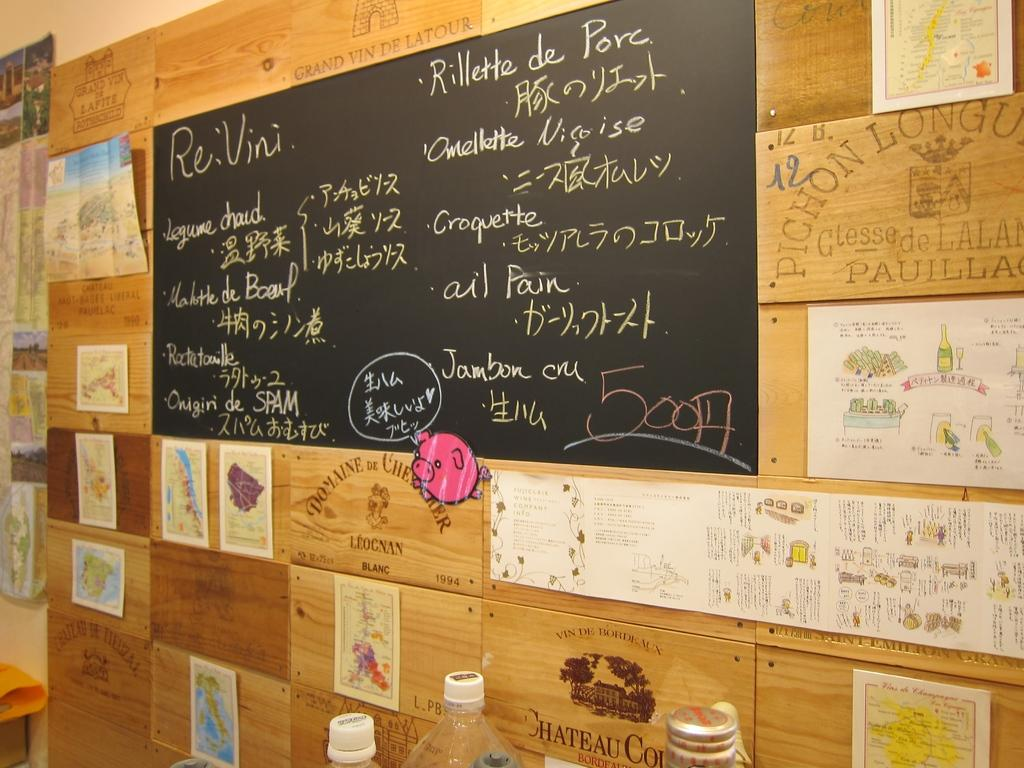<image>
Render a clear and concise summary of the photo. A Chalkboard mounted on a wall with various decorative wine box panels serving for an eatery serving legumes and omellettes. 